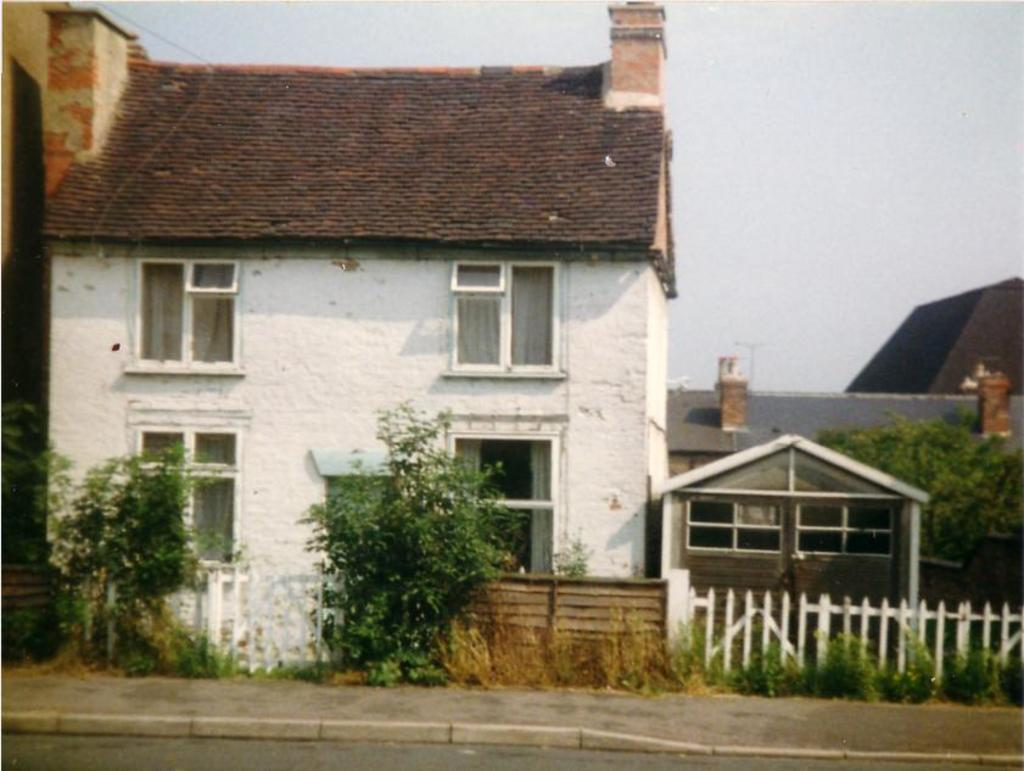What type of structures are present in the image? There are buildings with windows and roofs in the image. What can be seen in the foreground of the image? There is a fence and a group of trees in the foreground of the image. What is visible in the background of the image? The sky is visible in the background of the image. What type of cracker is being used as a club in the middle of the image? There is no cracker or club present in the image. 